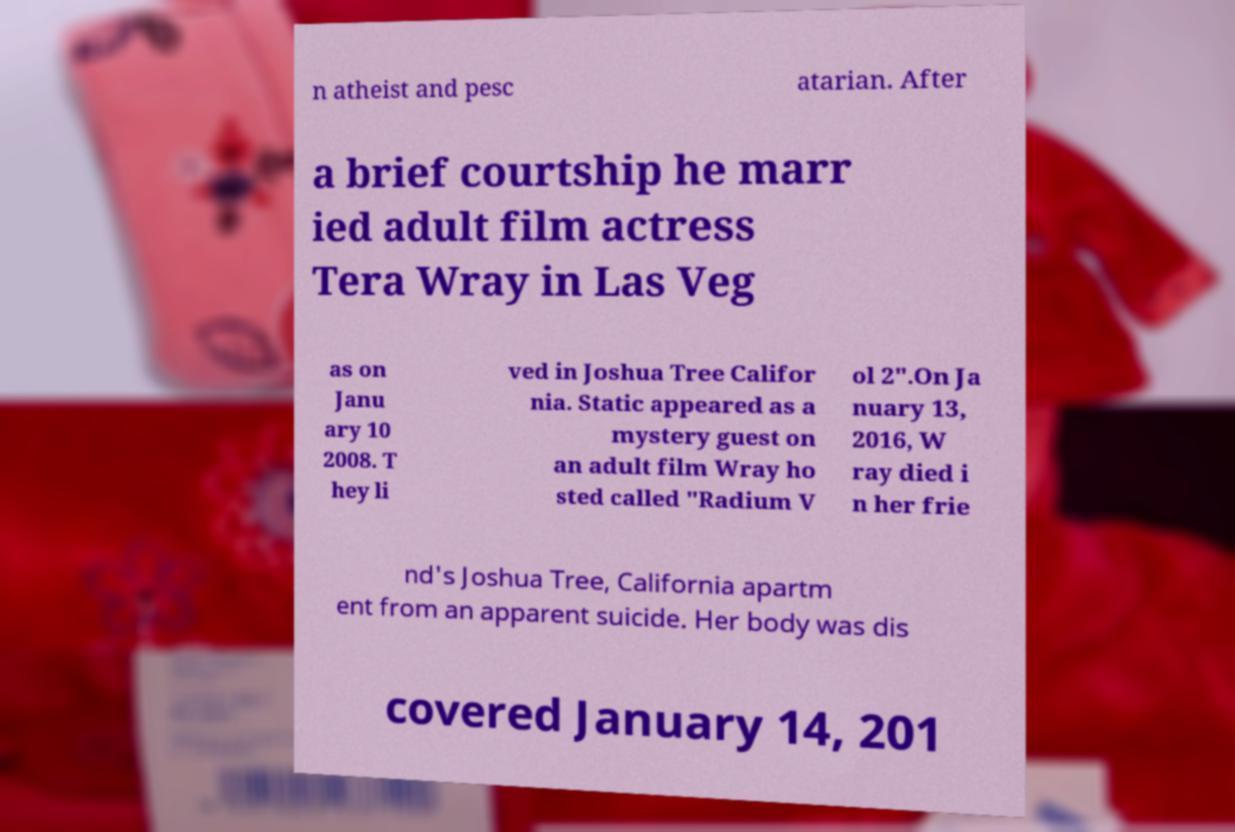There's text embedded in this image that I need extracted. Can you transcribe it verbatim? n atheist and pesc atarian. After a brief courtship he marr ied adult film actress Tera Wray in Las Veg as on Janu ary 10 2008. T hey li ved in Joshua Tree Califor nia. Static appeared as a mystery guest on an adult film Wray ho sted called "Radium V ol 2".On Ja nuary 13, 2016, W ray died i n her frie nd's Joshua Tree, California apartm ent from an apparent suicide. Her body was dis covered January 14, 201 